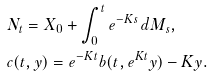<formula> <loc_0><loc_0><loc_500><loc_500>& N _ { t } = X _ { 0 } + \int _ { 0 } ^ { t } e ^ { - K s } \, d M _ { s } , \\ & c ( t , y ) = e ^ { - K t } b ( t , e ^ { K t } y ) - K y .</formula> 